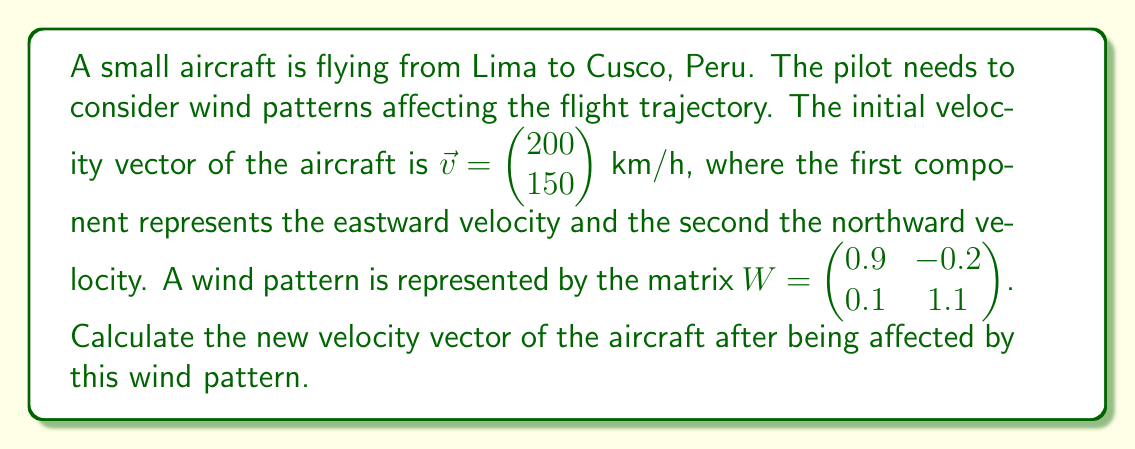Provide a solution to this math problem. To solve this problem, we need to multiply the wind pattern matrix by the initial velocity vector. This operation will give us the new velocity vector after the wind's effect.

Step 1: Set up the matrix multiplication
$$W\vec{v} = \begin{pmatrix} 0.9 & -0.2 \\ 0.1 & 1.1 \end{pmatrix} \begin{pmatrix} 200 \\ 150 \end{pmatrix}$$

Step 2: Perform the matrix multiplication
$$\begin{pmatrix} (0.9 \times 200) + (-0.2 \times 150) \\ (0.1 \times 200) + (1.1 \times 150) \end{pmatrix}$$

Step 3: Calculate the components
$$(0.9 \times 200) + (-0.2 \times 150) = 180 - 30 = 150$$
$$(0.1 \times 200) + (1.1 \times 150) = 20 + 165 = 185$$

Step 4: Write the final velocity vector
$$\vec{v}_{\text{new}} = \begin{pmatrix} 150 \\ 185 \end{pmatrix}$$

The new velocity vector shows that the aircraft's eastward velocity has decreased to 150 km/h, while its northward velocity has increased to 185 km/h due to the wind pattern.
Answer: $\vec{v}_{\text{new}} = \begin{pmatrix} 150 \\ 185 \end{pmatrix}$ km/h 